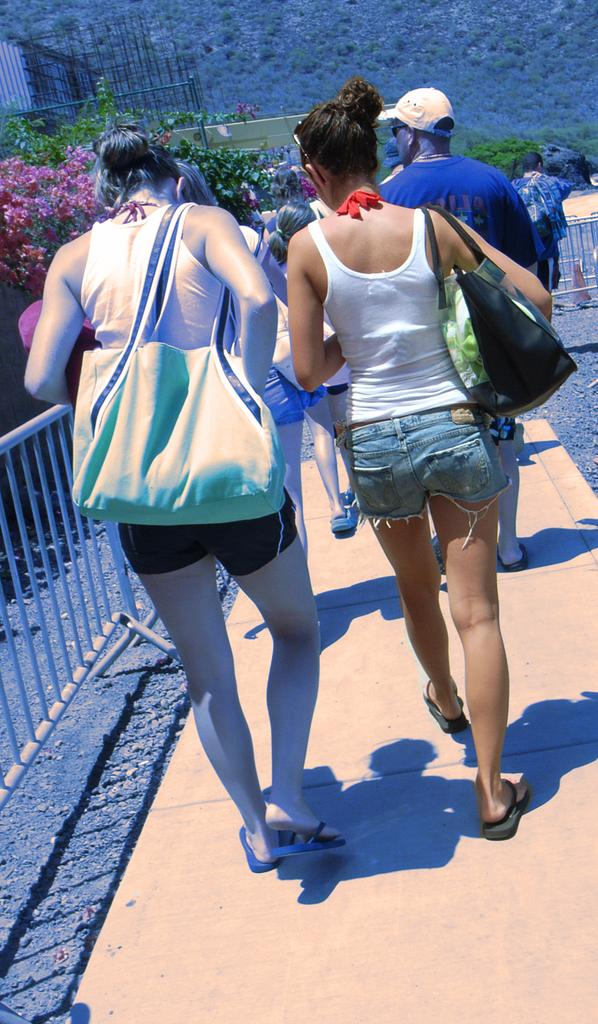What are the people in the image doing? There are many people walking in the image. Which direction are the people facing? The people are facing back. What are the people carrying? The people are carrying bags. Can you describe the path the people are walking on? There is a footpath in the image. What else can be seen in the image? There is a fence, sand, and plants in the image. What type of rings can be seen on the toad's fingers in the image? There is no toad or rings present in the image. 